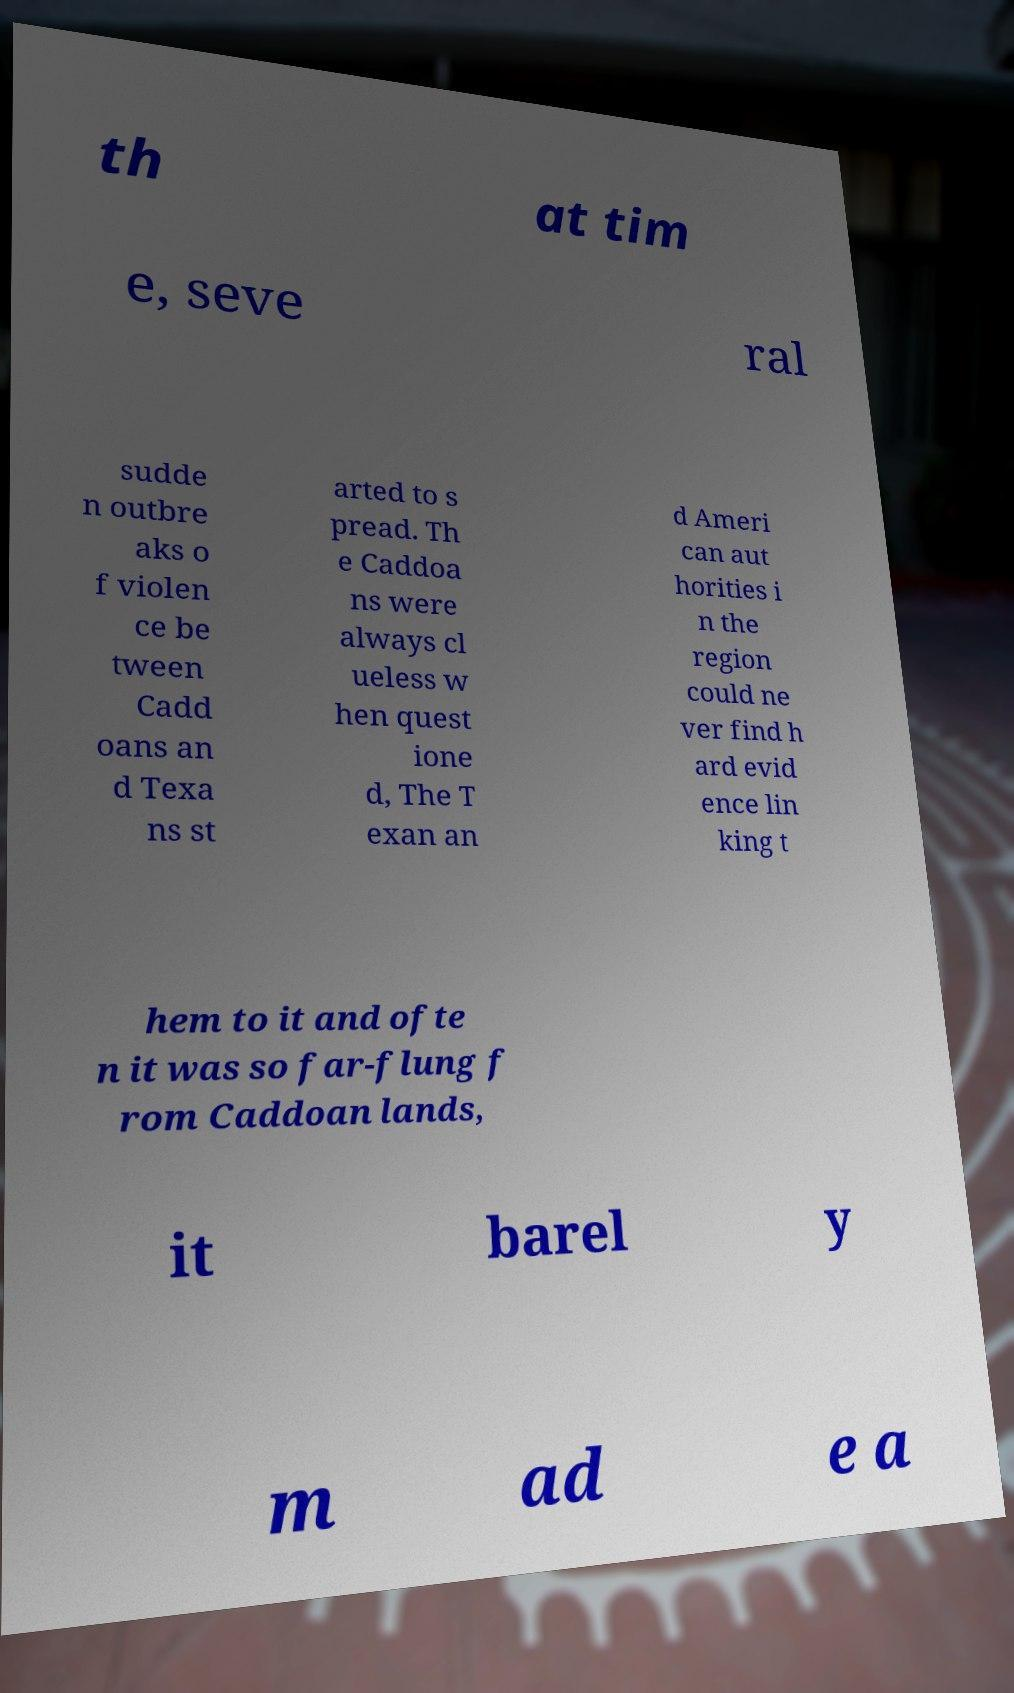There's text embedded in this image that I need extracted. Can you transcribe it verbatim? th at tim e, seve ral sudde n outbre aks o f violen ce be tween Cadd oans an d Texa ns st arted to s pread. Th e Caddoa ns were always cl ueless w hen quest ione d, The T exan an d Ameri can aut horities i n the region could ne ver find h ard evid ence lin king t hem to it and ofte n it was so far-flung f rom Caddoan lands, it barel y m ad e a 